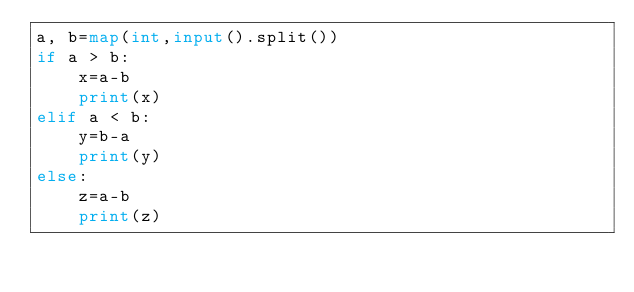Convert code to text. <code><loc_0><loc_0><loc_500><loc_500><_Python_>a, b=map(int,input().split())
if a > b:
    x=a-b
    print(x)
elif a < b:
    y=b-a
    print(y)
else:
    z=a-b
    print(z)
</code> 